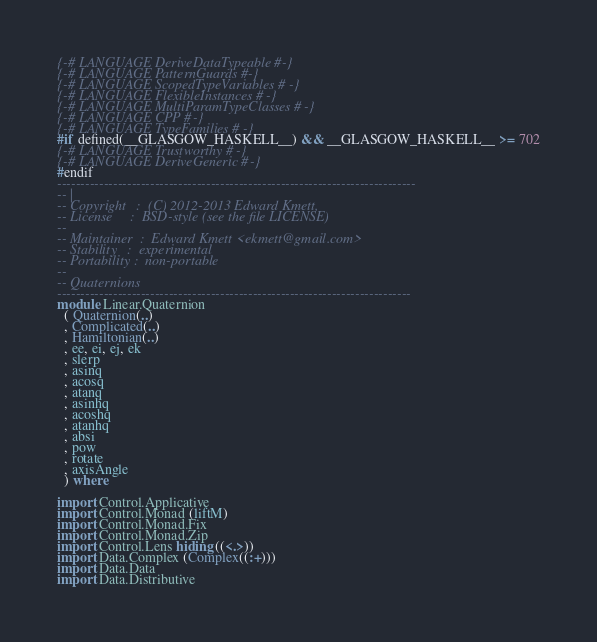Convert code to text. <code><loc_0><loc_0><loc_500><loc_500><_Haskell_>{-# LANGUAGE DeriveDataTypeable #-}
{-# LANGUAGE PatternGuards #-}
{-# LANGUAGE ScopedTypeVariables #-}
{-# LANGUAGE FlexibleInstances #-}
{-# LANGUAGE MultiParamTypeClasses #-}
{-# LANGUAGE CPP #-}
{-# LANGUAGE TypeFamilies #-}
#if defined(__GLASGOW_HASKELL__) && __GLASGOW_HASKELL__ >= 702
{-# LANGUAGE Trustworthy #-}
{-# LANGUAGE DeriveGeneric #-}
#endif
-----------------------------------------------------------------------------
-- |
-- Copyright   :  (C) 2012-2013 Edward Kmett,
-- License     :  BSD-style (see the file LICENSE)
--
-- Maintainer  :  Edward Kmett <ekmett@gmail.com>
-- Stability   :  experimental
-- Portability :  non-portable
--
-- Quaternions
----------------------------------------------------------------------------
module Linear.Quaternion
  ( Quaternion(..)
  , Complicated(..)
  , Hamiltonian(..)
  , ee, ei, ej, ek
  , slerp
  , asinq
  , acosq
  , atanq
  , asinhq
  , acoshq
  , atanhq
  , absi
  , pow
  , rotate
  , axisAngle
  ) where

import Control.Applicative
import Control.Monad (liftM)
import Control.Monad.Fix
import Control.Monad.Zip
import Control.Lens hiding ((<.>))
import Data.Complex (Complex((:+)))
import Data.Data
import Data.Distributive</code> 